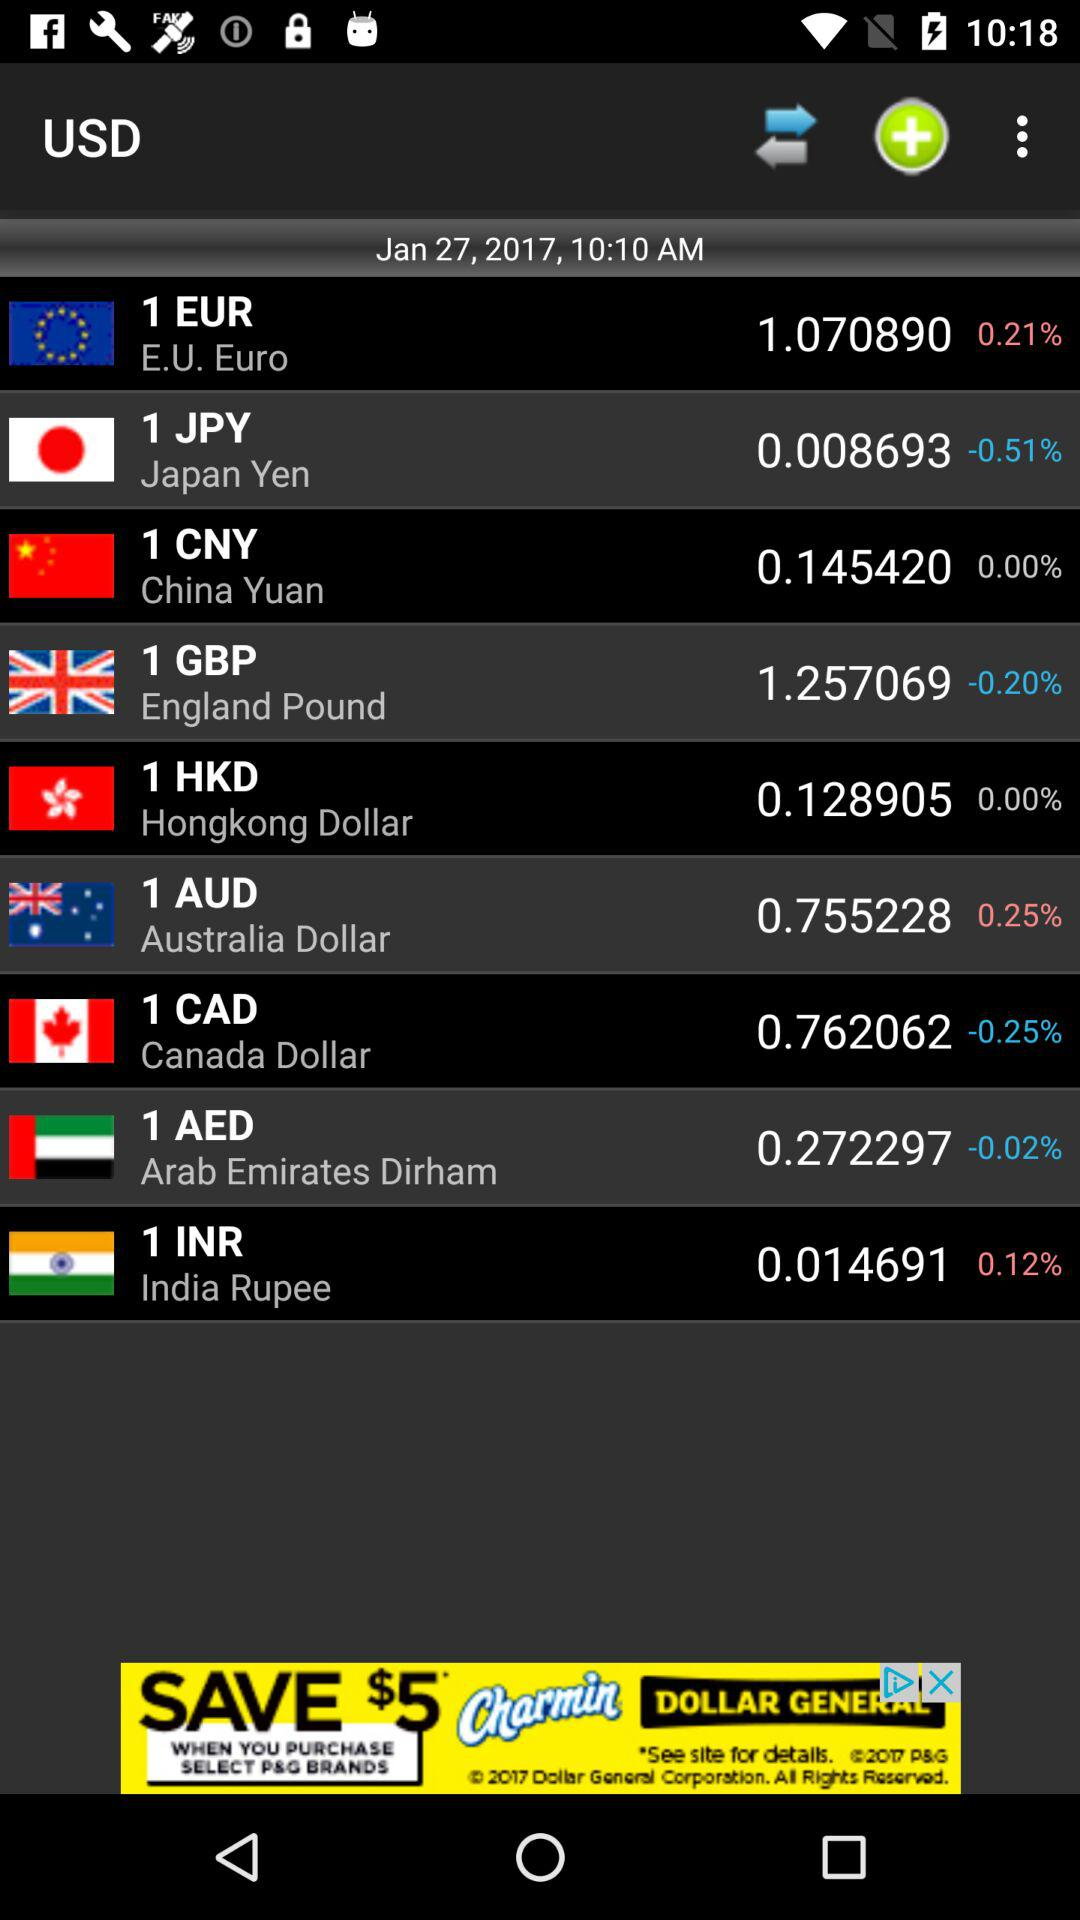What is the price of "1 EUR"? The price of "1 EUR" is 1.070890 USD. 